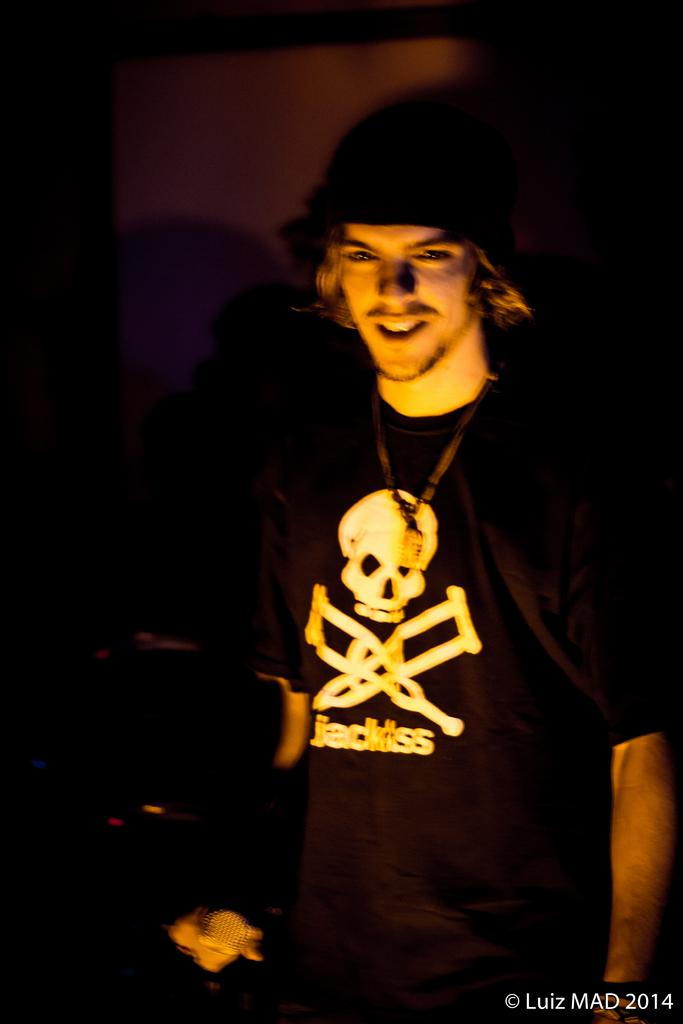What is the main subject of the image? There is a man in the image. What is the man wearing on his upper body? The man is wearing a black t-shirt. What type of headwear is the man wearing? The man is wearing a cap. What expression does the man have in the image? The man is smiling. How would you describe the background of the image? The background of the image is blurry. What type of glue is the man using in the image? There is no glue present in the image, and the man is not using any glue. Can you see a spoon in the man's hand in the image? There is no spoon visible in the man's hand or anywhere else in the image. 